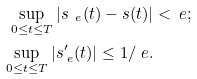<formula> <loc_0><loc_0><loc_500><loc_500>\sup _ { 0 \leq t \leq T } | s _ { \ e } ( t ) - s ( t ) | & < \ e ; \\ \sup _ { 0 \leq t \leq T } | s ^ { \prime } _ { \ e } ( t ) | \leq 1 / \ e .</formula> 